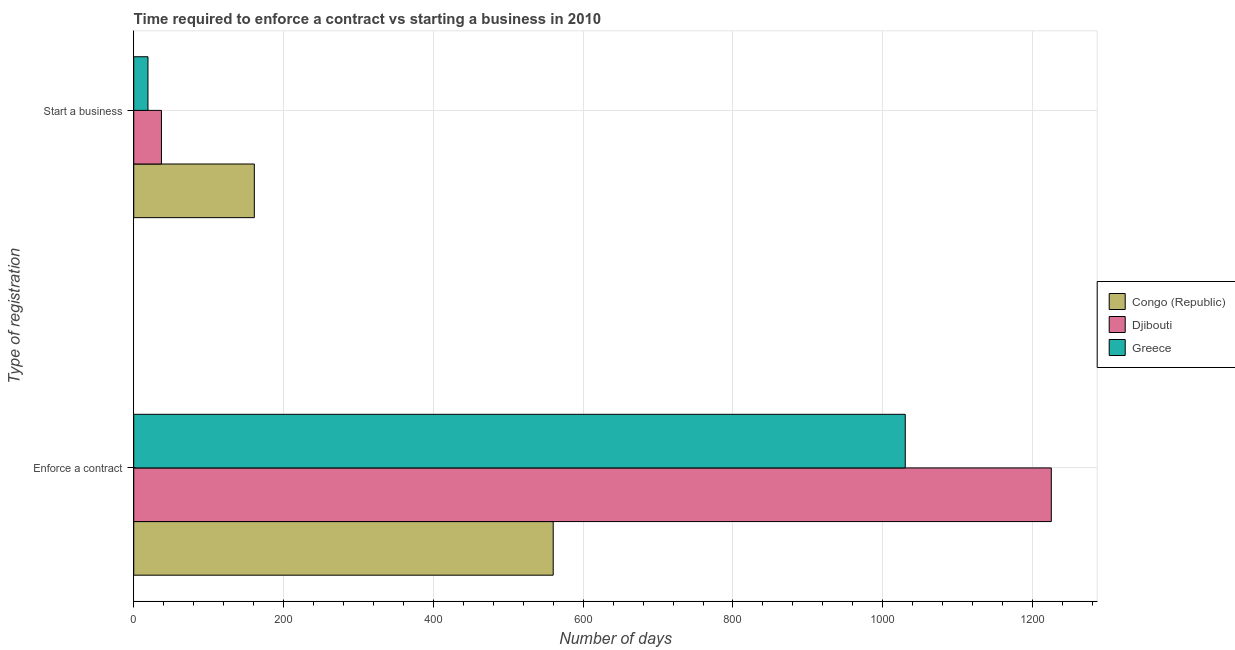How many different coloured bars are there?
Ensure brevity in your answer.  3. How many bars are there on the 1st tick from the bottom?
Give a very brief answer. 3. What is the label of the 2nd group of bars from the top?
Ensure brevity in your answer.  Enforce a contract. What is the number of days to start a business in Greece?
Provide a succinct answer. 19. Across all countries, what is the maximum number of days to enforece a contract?
Provide a short and direct response. 1225. Across all countries, what is the minimum number of days to start a business?
Make the answer very short. 19. In which country was the number of days to start a business maximum?
Provide a succinct answer. Congo (Republic). In which country was the number of days to enforece a contract minimum?
Give a very brief answer. Congo (Republic). What is the total number of days to start a business in the graph?
Make the answer very short. 217. What is the difference between the number of days to start a business in Djibouti and that in Greece?
Make the answer very short. 18. What is the difference between the number of days to start a business in Greece and the number of days to enforece a contract in Congo (Republic)?
Give a very brief answer. -541. What is the average number of days to start a business per country?
Keep it short and to the point. 72.33. What is the difference between the number of days to enforece a contract and number of days to start a business in Djibouti?
Provide a short and direct response. 1188. What is the ratio of the number of days to start a business in Greece to that in Congo (Republic)?
Give a very brief answer. 0.12. Is the number of days to enforece a contract in Greece less than that in Congo (Republic)?
Offer a very short reply. No. In how many countries, is the number of days to start a business greater than the average number of days to start a business taken over all countries?
Provide a short and direct response. 1. What does the 2nd bar from the top in Enforce a contract represents?
Ensure brevity in your answer.  Djibouti. What does the 3rd bar from the bottom in Start a business represents?
Keep it short and to the point. Greece. How many bars are there?
Offer a very short reply. 6. Are all the bars in the graph horizontal?
Your answer should be compact. Yes. How many countries are there in the graph?
Keep it short and to the point. 3. How many legend labels are there?
Your answer should be compact. 3. What is the title of the graph?
Your answer should be compact. Time required to enforce a contract vs starting a business in 2010. Does "Estonia" appear as one of the legend labels in the graph?
Your answer should be compact. No. What is the label or title of the X-axis?
Keep it short and to the point. Number of days. What is the label or title of the Y-axis?
Provide a succinct answer. Type of registration. What is the Number of days in Congo (Republic) in Enforce a contract?
Provide a short and direct response. 560. What is the Number of days of Djibouti in Enforce a contract?
Your answer should be compact. 1225. What is the Number of days in Greece in Enforce a contract?
Offer a very short reply. 1030. What is the Number of days in Congo (Republic) in Start a business?
Your answer should be compact. 161. What is the Number of days of Djibouti in Start a business?
Offer a terse response. 37. Across all Type of registration, what is the maximum Number of days in Congo (Republic)?
Make the answer very short. 560. Across all Type of registration, what is the maximum Number of days in Djibouti?
Offer a very short reply. 1225. Across all Type of registration, what is the maximum Number of days of Greece?
Keep it short and to the point. 1030. Across all Type of registration, what is the minimum Number of days of Congo (Republic)?
Your response must be concise. 161. Across all Type of registration, what is the minimum Number of days in Greece?
Ensure brevity in your answer.  19. What is the total Number of days in Congo (Republic) in the graph?
Your answer should be very brief. 721. What is the total Number of days of Djibouti in the graph?
Your answer should be compact. 1262. What is the total Number of days of Greece in the graph?
Make the answer very short. 1049. What is the difference between the Number of days of Congo (Republic) in Enforce a contract and that in Start a business?
Provide a succinct answer. 399. What is the difference between the Number of days in Djibouti in Enforce a contract and that in Start a business?
Provide a short and direct response. 1188. What is the difference between the Number of days of Greece in Enforce a contract and that in Start a business?
Provide a succinct answer. 1011. What is the difference between the Number of days in Congo (Republic) in Enforce a contract and the Number of days in Djibouti in Start a business?
Your response must be concise. 523. What is the difference between the Number of days of Congo (Republic) in Enforce a contract and the Number of days of Greece in Start a business?
Make the answer very short. 541. What is the difference between the Number of days of Djibouti in Enforce a contract and the Number of days of Greece in Start a business?
Ensure brevity in your answer.  1206. What is the average Number of days in Congo (Republic) per Type of registration?
Offer a very short reply. 360.5. What is the average Number of days of Djibouti per Type of registration?
Provide a short and direct response. 631. What is the average Number of days of Greece per Type of registration?
Ensure brevity in your answer.  524.5. What is the difference between the Number of days in Congo (Republic) and Number of days in Djibouti in Enforce a contract?
Keep it short and to the point. -665. What is the difference between the Number of days of Congo (Republic) and Number of days of Greece in Enforce a contract?
Your answer should be compact. -470. What is the difference between the Number of days of Djibouti and Number of days of Greece in Enforce a contract?
Ensure brevity in your answer.  195. What is the difference between the Number of days in Congo (Republic) and Number of days in Djibouti in Start a business?
Ensure brevity in your answer.  124. What is the difference between the Number of days of Congo (Republic) and Number of days of Greece in Start a business?
Provide a short and direct response. 142. What is the ratio of the Number of days of Congo (Republic) in Enforce a contract to that in Start a business?
Make the answer very short. 3.48. What is the ratio of the Number of days of Djibouti in Enforce a contract to that in Start a business?
Your response must be concise. 33.11. What is the ratio of the Number of days of Greece in Enforce a contract to that in Start a business?
Ensure brevity in your answer.  54.21. What is the difference between the highest and the second highest Number of days in Congo (Republic)?
Offer a very short reply. 399. What is the difference between the highest and the second highest Number of days of Djibouti?
Provide a succinct answer. 1188. What is the difference between the highest and the second highest Number of days of Greece?
Your answer should be very brief. 1011. What is the difference between the highest and the lowest Number of days in Congo (Republic)?
Your answer should be compact. 399. What is the difference between the highest and the lowest Number of days in Djibouti?
Give a very brief answer. 1188. What is the difference between the highest and the lowest Number of days in Greece?
Keep it short and to the point. 1011. 